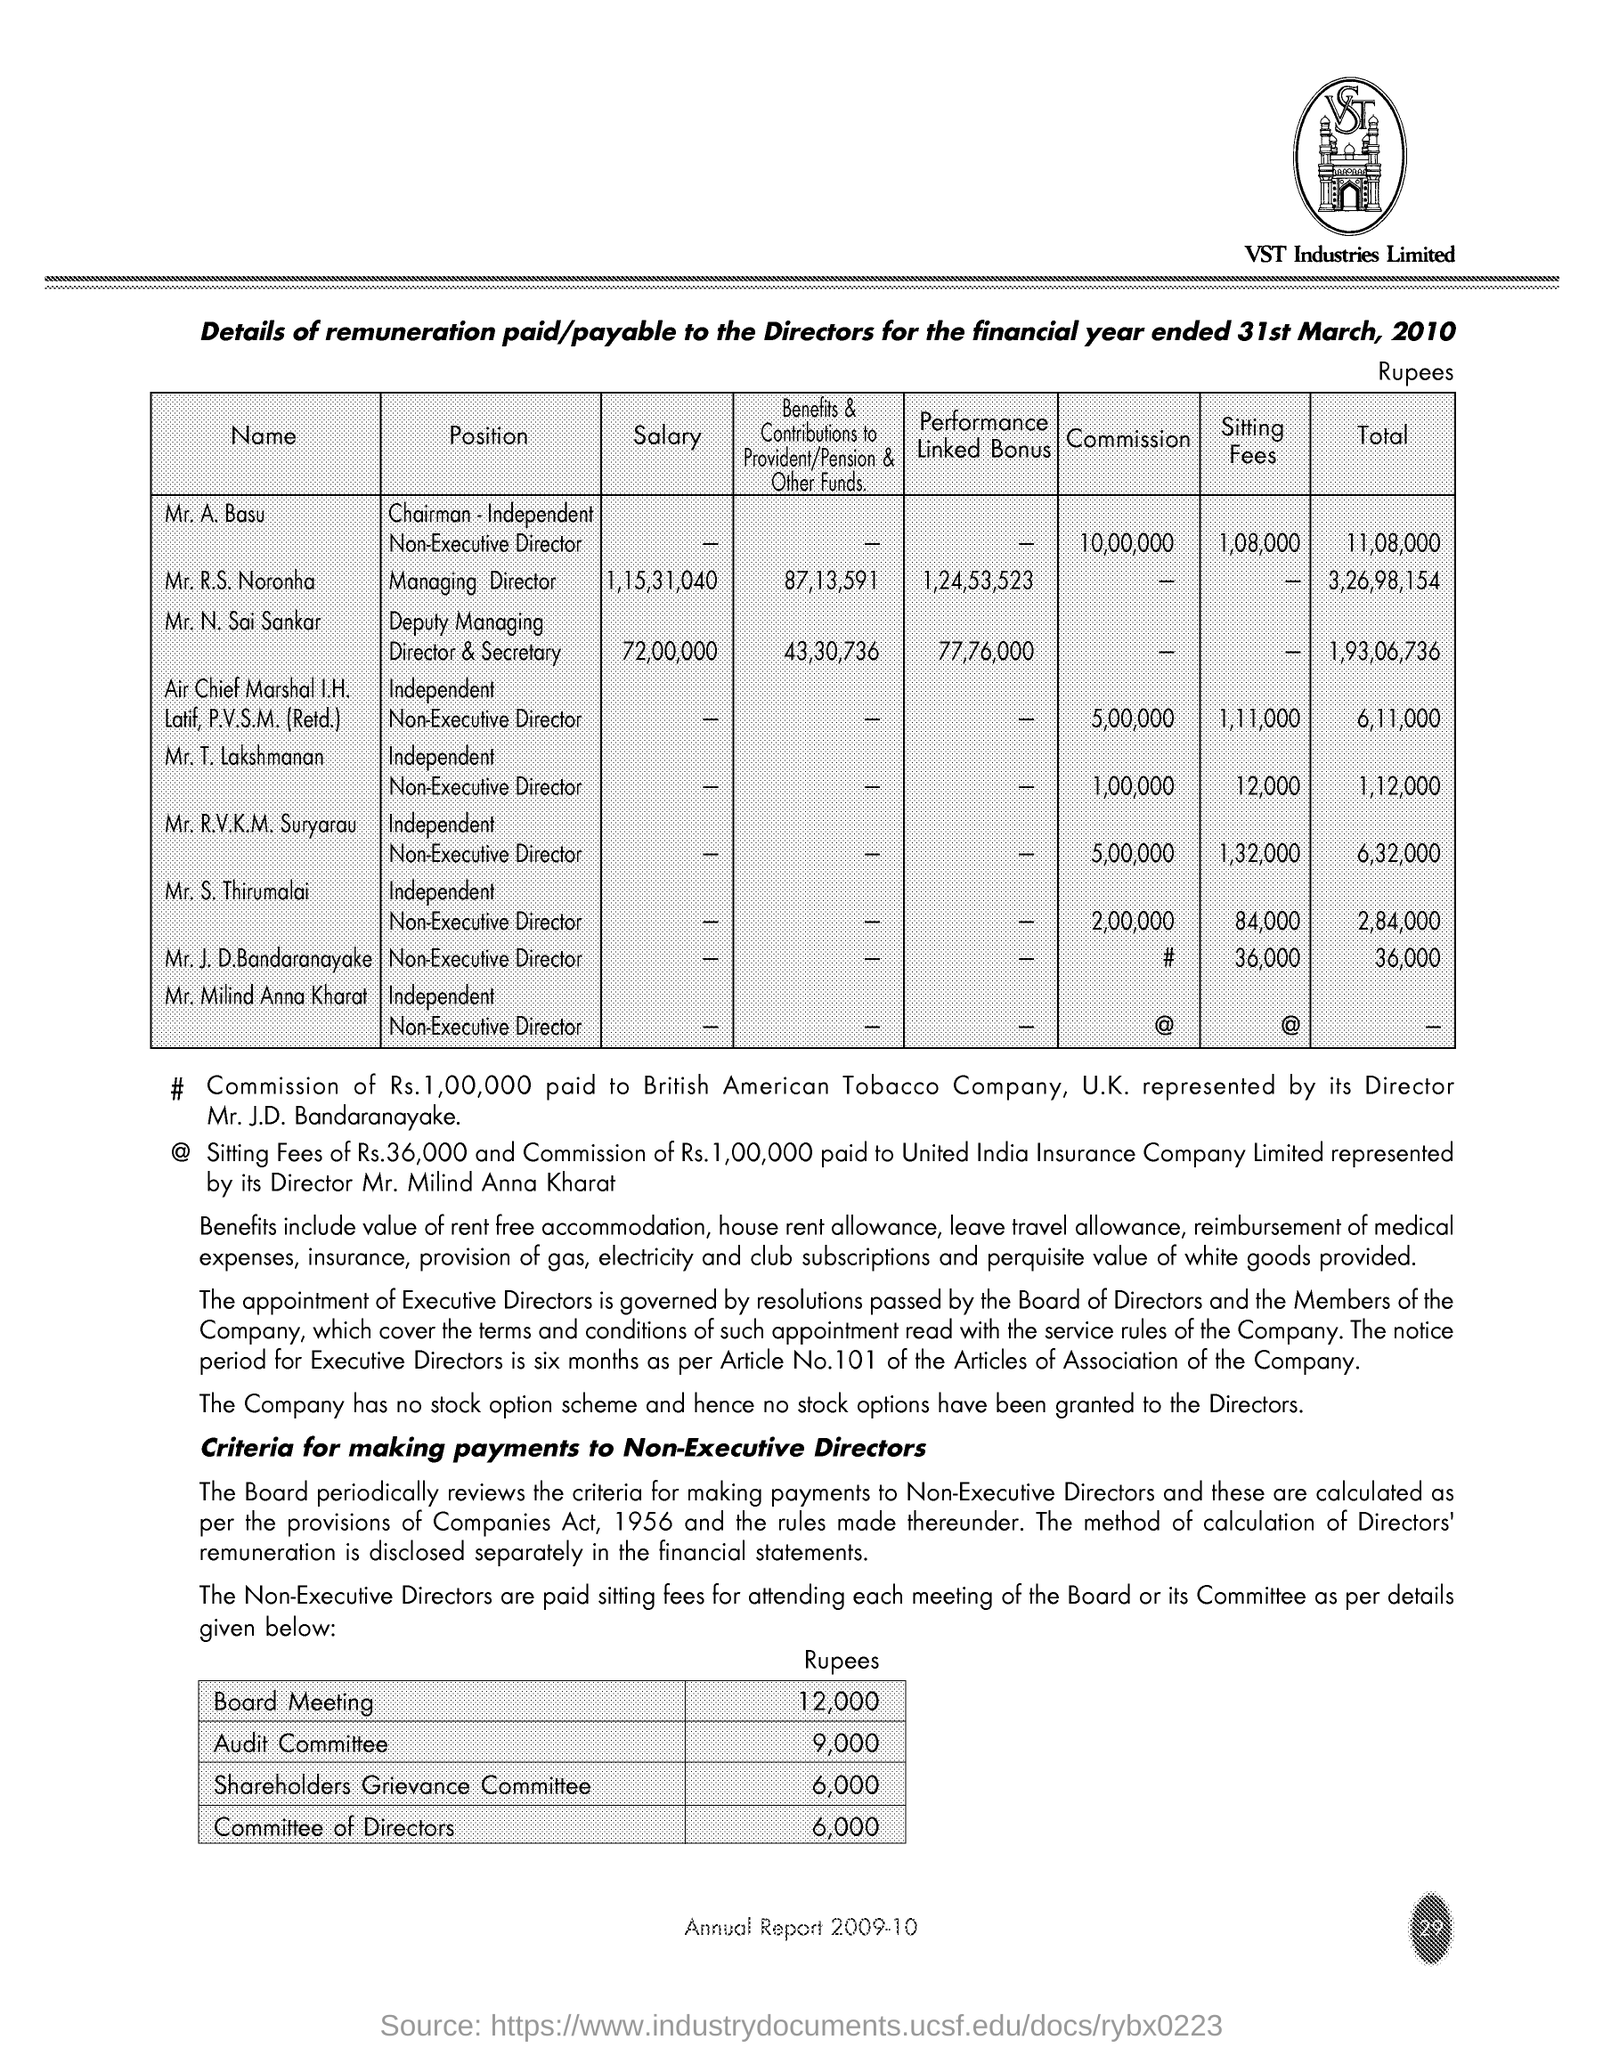How much Setting fees for Mr.T. Lakshmanan?
Ensure brevity in your answer.  12,000. 